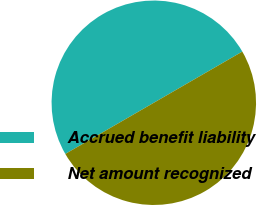Convert chart to OTSL. <chart><loc_0><loc_0><loc_500><loc_500><pie_chart><fcel>Accrued benefit liability<fcel>Net amount recognized<nl><fcel>50.0%<fcel>50.0%<nl></chart> 